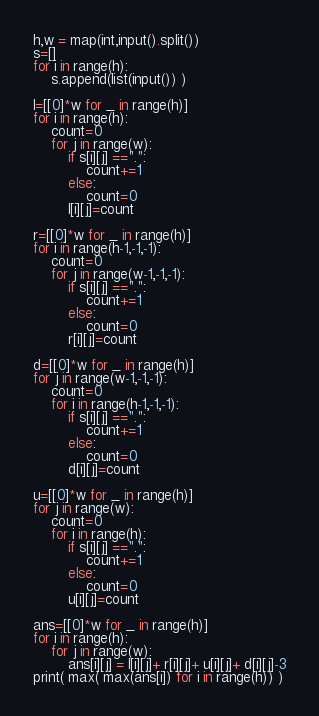Convert code to text. <code><loc_0><loc_0><loc_500><loc_500><_Python_>h,w = map(int,input().split())
s=[]
for i in range(h):
    s.append(list(input()) )

l=[[0]*w for _ in range(h)]
for i in range(h):
    count=0
    for j in range(w):
        if s[i][j] ==".":
            count+=1
        else:
            count=0
        l[i][j]=count
        
r=[[0]*w for _ in range(h)]
for i in range(h-1,-1,-1):
    count=0
    for j in range(w-1,-1,-1):
        if s[i][j] ==".":
            count+=1
        else:
            count=0
        r[i][j]=count
                
d=[[0]*w for _ in range(h)]
for j in range(w-1,-1,-1):
    count=0
    for i in range(h-1,-1,-1):
        if s[i][j] ==".":
            count+=1
        else:
            count=0
        d[i][j]=count
                
u=[[0]*w for _ in range(h)]
for j in range(w):
    count=0
    for i in range(h):
        if s[i][j] ==".":
            count+=1
        else:
            count=0
        u[i][j]=count

ans=[[0]*w for _ in range(h)]
for i in range(h):
    for j in range(w):
        ans[i][j] = l[i][j]+ r[i][j]+ u[i][j]+ d[i][j]-3
print( max( max(ans[i]) for i in range(h)) )</code> 